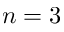<formula> <loc_0><loc_0><loc_500><loc_500>n = 3</formula> 